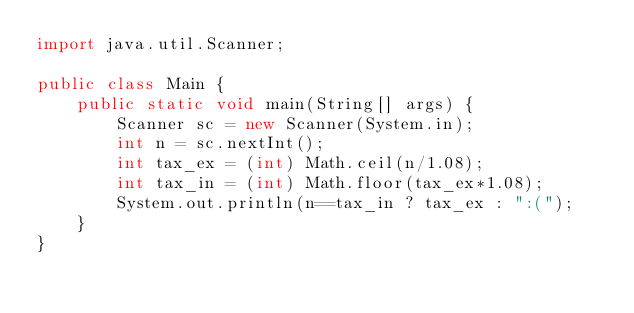Convert code to text. <code><loc_0><loc_0><loc_500><loc_500><_Java_>import java.util.Scanner;

public class Main {
    public static void main(String[] args) {
        Scanner sc = new Scanner(System.in);
        int n = sc.nextInt();
        int tax_ex = (int) Math.ceil(n/1.08);
        int tax_in = (int) Math.floor(tax_ex*1.08);
        System.out.println(n==tax_in ? tax_ex : ":(");
    }
}</code> 